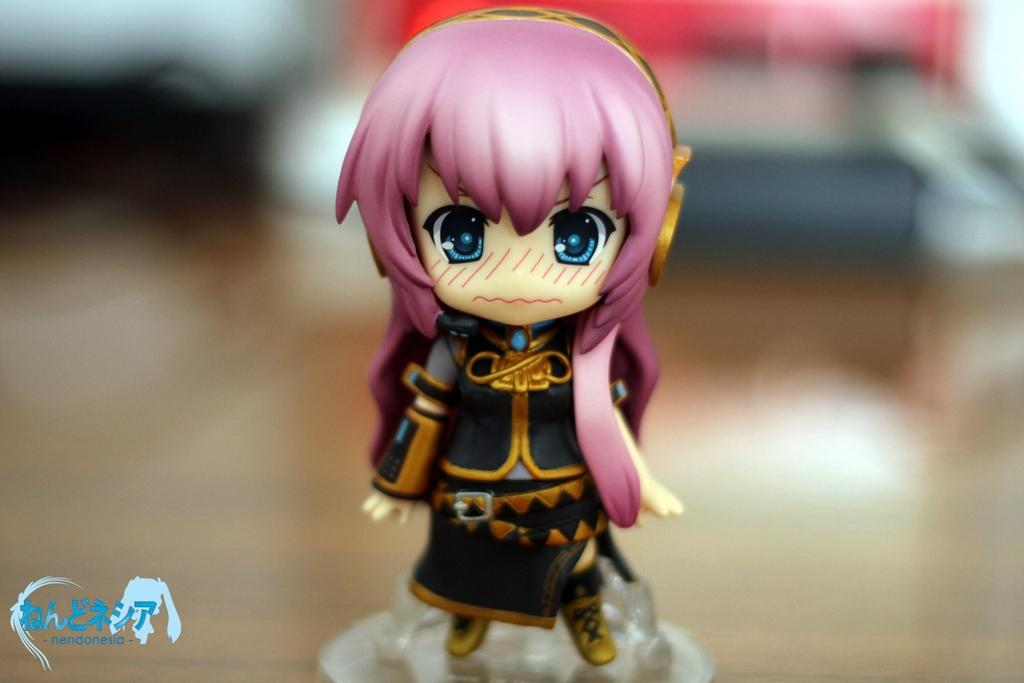What is the main subject in the image? There is a doll in the image. Is there any text or symbol in the image? Yes, there is a logo at the left bottom of the image. How would you describe the background of the image? The background of the image is blurry. What type of hand can be seen holding the doll in the image? There is no hand visible in the image; only the doll and the logo are present. Are there any bushes or plants in the background of the image? The background of the image is blurry, and there is no indication of bushes or plants. 